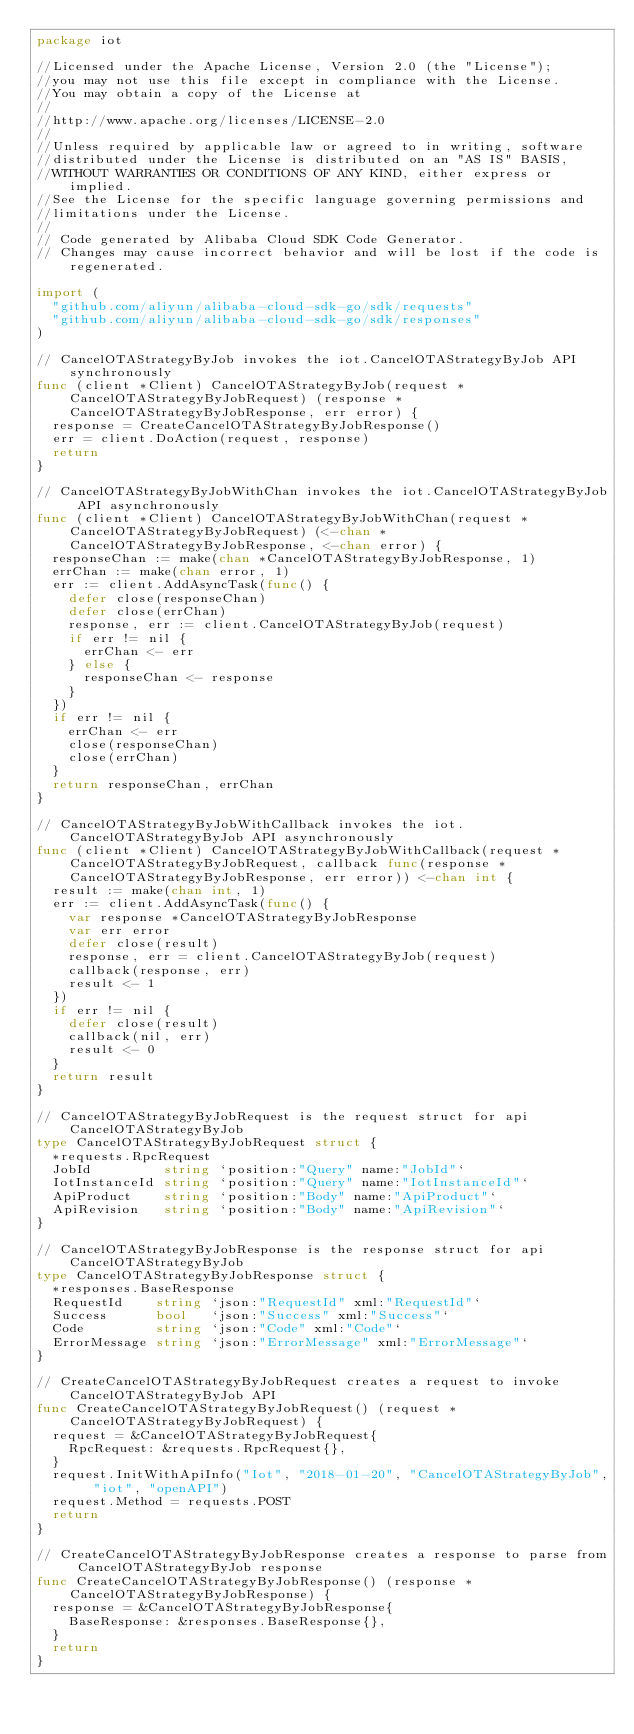Convert code to text. <code><loc_0><loc_0><loc_500><loc_500><_Go_>package iot

//Licensed under the Apache License, Version 2.0 (the "License");
//you may not use this file except in compliance with the License.
//You may obtain a copy of the License at
//
//http://www.apache.org/licenses/LICENSE-2.0
//
//Unless required by applicable law or agreed to in writing, software
//distributed under the License is distributed on an "AS IS" BASIS,
//WITHOUT WARRANTIES OR CONDITIONS OF ANY KIND, either express or implied.
//See the License for the specific language governing permissions and
//limitations under the License.
//
// Code generated by Alibaba Cloud SDK Code Generator.
// Changes may cause incorrect behavior and will be lost if the code is regenerated.

import (
	"github.com/aliyun/alibaba-cloud-sdk-go/sdk/requests"
	"github.com/aliyun/alibaba-cloud-sdk-go/sdk/responses"
)

// CancelOTAStrategyByJob invokes the iot.CancelOTAStrategyByJob API synchronously
func (client *Client) CancelOTAStrategyByJob(request *CancelOTAStrategyByJobRequest) (response *CancelOTAStrategyByJobResponse, err error) {
	response = CreateCancelOTAStrategyByJobResponse()
	err = client.DoAction(request, response)
	return
}

// CancelOTAStrategyByJobWithChan invokes the iot.CancelOTAStrategyByJob API asynchronously
func (client *Client) CancelOTAStrategyByJobWithChan(request *CancelOTAStrategyByJobRequest) (<-chan *CancelOTAStrategyByJobResponse, <-chan error) {
	responseChan := make(chan *CancelOTAStrategyByJobResponse, 1)
	errChan := make(chan error, 1)
	err := client.AddAsyncTask(func() {
		defer close(responseChan)
		defer close(errChan)
		response, err := client.CancelOTAStrategyByJob(request)
		if err != nil {
			errChan <- err
		} else {
			responseChan <- response
		}
	})
	if err != nil {
		errChan <- err
		close(responseChan)
		close(errChan)
	}
	return responseChan, errChan
}

// CancelOTAStrategyByJobWithCallback invokes the iot.CancelOTAStrategyByJob API asynchronously
func (client *Client) CancelOTAStrategyByJobWithCallback(request *CancelOTAStrategyByJobRequest, callback func(response *CancelOTAStrategyByJobResponse, err error)) <-chan int {
	result := make(chan int, 1)
	err := client.AddAsyncTask(func() {
		var response *CancelOTAStrategyByJobResponse
		var err error
		defer close(result)
		response, err = client.CancelOTAStrategyByJob(request)
		callback(response, err)
		result <- 1
	})
	if err != nil {
		defer close(result)
		callback(nil, err)
		result <- 0
	}
	return result
}

// CancelOTAStrategyByJobRequest is the request struct for api CancelOTAStrategyByJob
type CancelOTAStrategyByJobRequest struct {
	*requests.RpcRequest
	JobId         string `position:"Query" name:"JobId"`
	IotInstanceId string `position:"Query" name:"IotInstanceId"`
	ApiProduct    string `position:"Body" name:"ApiProduct"`
	ApiRevision   string `position:"Body" name:"ApiRevision"`
}

// CancelOTAStrategyByJobResponse is the response struct for api CancelOTAStrategyByJob
type CancelOTAStrategyByJobResponse struct {
	*responses.BaseResponse
	RequestId    string `json:"RequestId" xml:"RequestId"`
	Success      bool   `json:"Success" xml:"Success"`
	Code         string `json:"Code" xml:"Code"`
	ErrorMessage string `json:"ErrorMessage" xml:"ErrorMessage"`
}

// CreateCancelOTAStrategyByJobRequest creates a request to invoke CancelOTAStrategyByJob API
func CreateCancelOTAStrategyByJobRequest() (request *CancelOTAStrategyByJobRequest) {
	request = &CancelOTAStrategyByJobRequest{
		RpcRequest: &requests.RpcRequest{},
	}
	request.InitWithApiInfo("Iot", "2018-01-20", "CancelOTAStrategyByJob", "iot", "openAPI")
	request.Method = requests.POST
	return
}

// CreateCancelOTAStrategyByJobResponse creates a response to parse from CancelOTAStrategyByJob response
func CreateCancelOTAStrategyByJobResponse() (response *CancelOTAStrategyByJobResponse) {
	response = &CancelOTAStrategyByJobResponse{
		BaseResponse: &responses.BaseResponse{},
	}
	return
}
</code> 